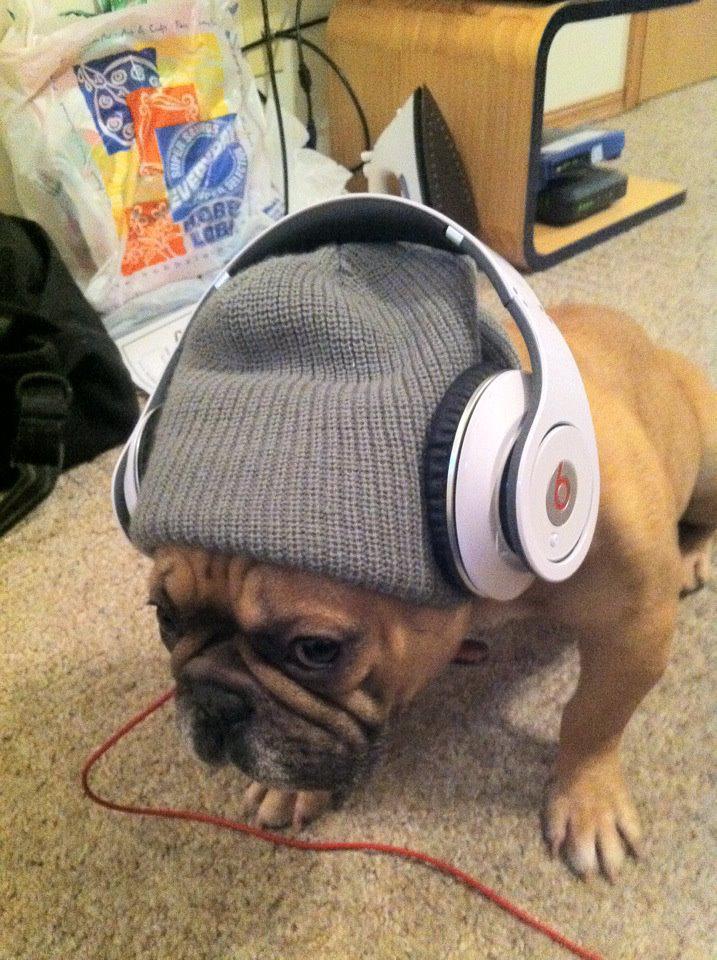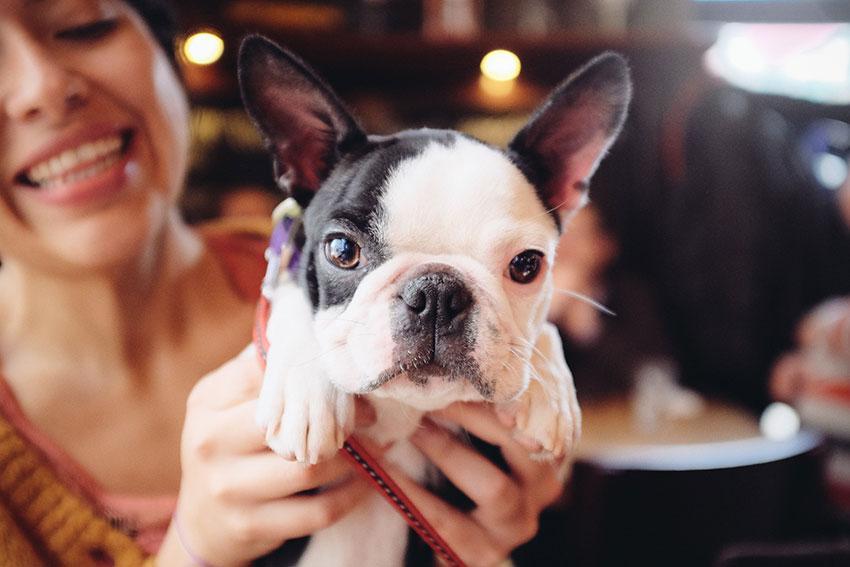The first image is the image on the left, the second image is the image on the right. Examine the images to the left and right. Is the description "A dog's ears are covered by articles of clothing." accurate? Answer yes or no. Yes. The first image is the image on the left, the second image is the image on the right. Considering the images on both sides, is "The dog in the left image is being touched by a human hand." valid? Answer yes or no. No. 